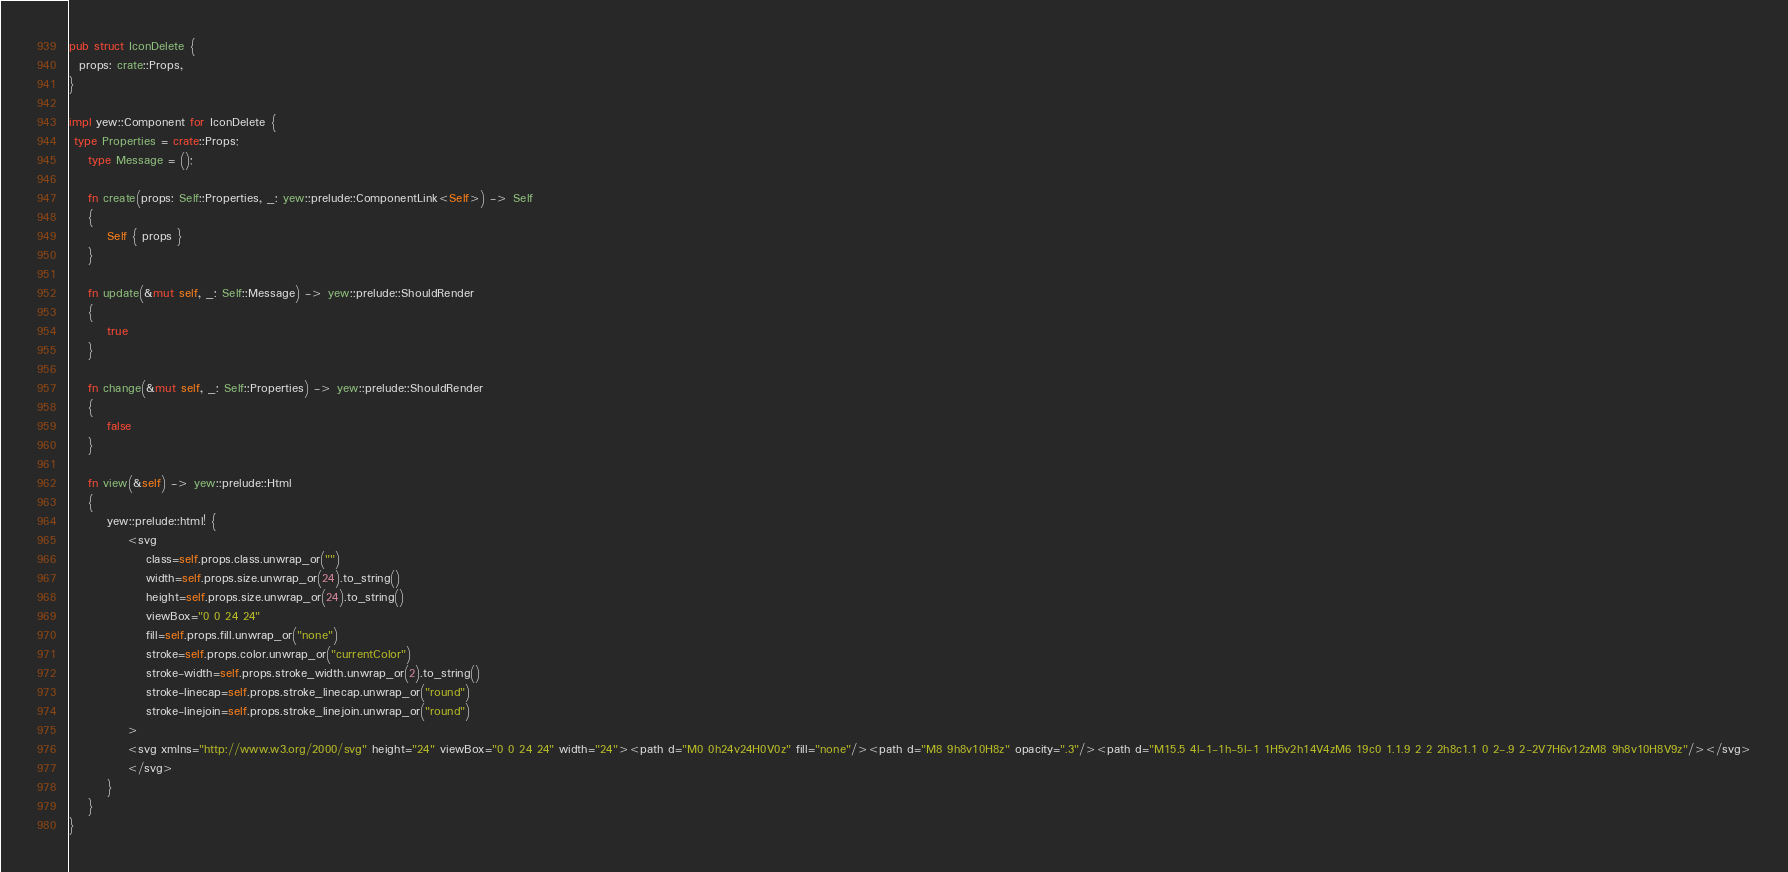Convert code to text. <code><loc_0><loc_0><loc_500><loc_500><_Rust_>
pub struct IconDelete {
  props: crate::Props,
}

impl yew::Component for IconDelete {
 type Properties = crate::Props;
    type Message = ();

    fn create(props: Self::Properties, _: yew::prelude::ComponentLink<Self>) -> Self
    {
        Self { props }
    }

    fn update(&mut self, _: Self::Message) -> yew::prelude::ShouldRender
    {
        true
    }

    fn change(&mut self, _: Self::Properties) -> yew::prelude::ShouldRender
    {
        false
    }

    fn view(&self) -> yew::prelude::Html
    {
        yew::prelude::html! {
            <svg
                class=self.props.class.unwrap_or("")
                width=self.props.size.unwrap_or(24).to_string()
                height=self.props.size.unwrap_or(24).to_string()
                viewBox="0 0 24 24"
                fill=self.props.fill.unwrap_or("none")
                stroke=self.props.color.unwrap_or("currentColor")
                stroke-width=self.props.stroke_width.unwrap_or(2).to_string()
                stroke-linecap=self.props.stroke_linecap.unwrap_or("round")
                stroke-linejoin=self.props.stroke_linejoin.unwrap_or("round")
            >
            <svg xmlns="http://www.w3.org/2000/svg" height="24" viewBox="0 0 24 24" width="24"><path d="M0 0h24v24H0V0z" fill="none"/><path d="M8 9h8v10H8z" opacity=".3"/><path d="M15.5 4l-1-1h-5l-1 1H5v2h14V4zM6 19c0 1.1.9 2 2 2h8c1.1 0 2-.9 2-2V7H6v12zM8 9h8v10H8V9z"/></svg>
            </svg>
        }
    }
}


</code> 